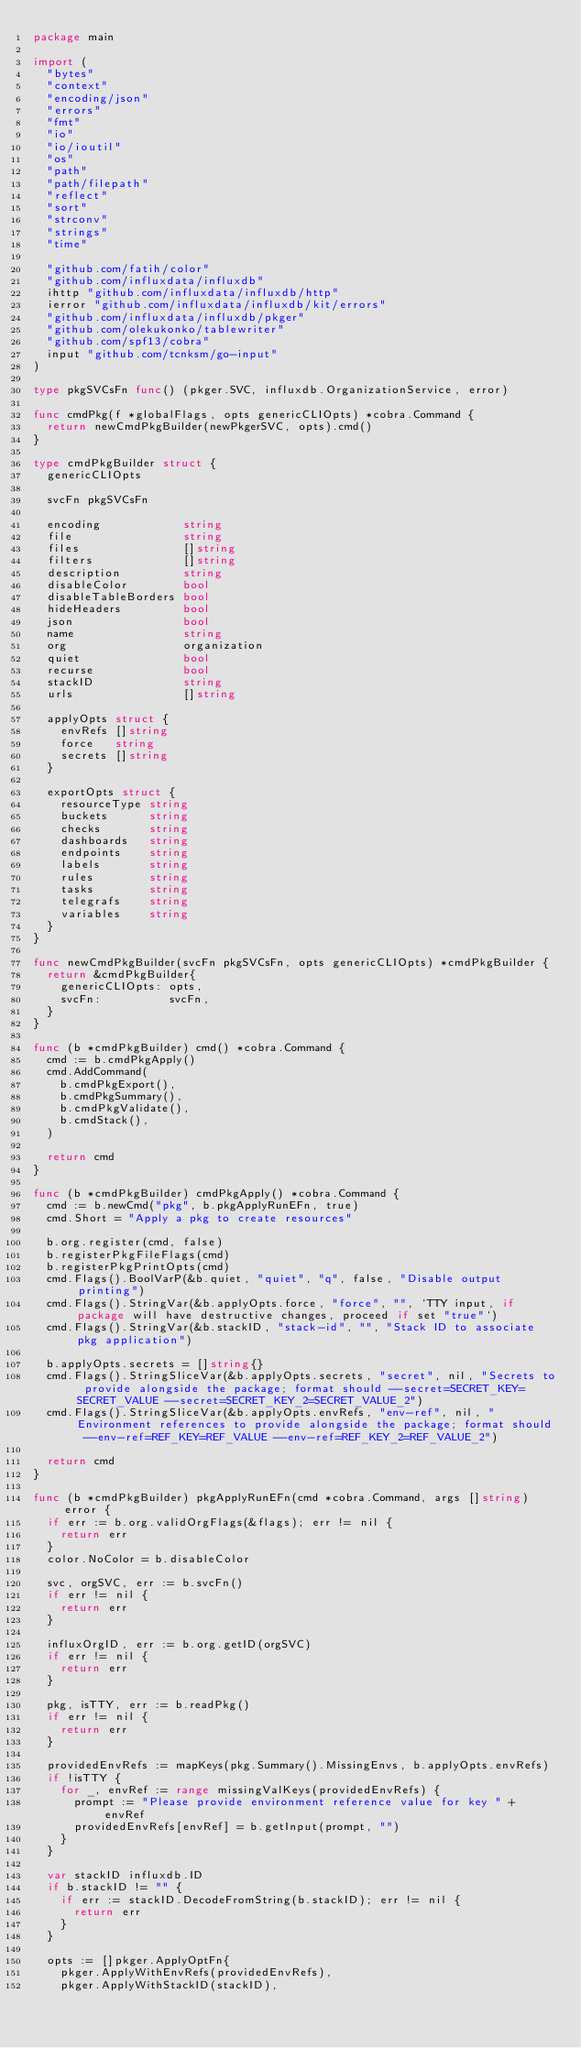Convert code to text. <code><loc_0><loc_0><loc_500><loc_500><_Go_>package main

import (
	"bytes"
	"context"
	"encoding/json"
	"errors"
	"fmt"
	"io"
	"io/ioutil"
	"os"
	"path"
	"path/filepath"
	"reflect"
	"sort"
	"strconv"
	"strings"
	"time"

	"github.com/fatih/color"
	"github.com/influxdata/influxdb"
	ihttp "github.com/influxdata/influxdb/http"
	ierror "github.com/influxdata/influxdb/kit/errors"
	"github.com/influxdata/influxdb/pkger"
	"github.com/olekukonko/tablewriter"
	"github.com/spf13/cobra"
	input "github.com/tcnksm/go-input"
)

type pkgSVCsFn func() (pkger.SVC, influxdb.OrganizationService, error)

func cmdPkg(f *globalFlags, opts genericCLIOpts) *cobra.Command {
	return newCmdPkgBuilder(newPkgerSVC, opts).cmd()
}

type cmdPkgBuilder struct {
	genericCLIOpts

	svcFn pkgSVCsFn

	encoding            string
	file                string
	files               []string
	filters             []string
	description         string
	disableColor        bool
	disableTableBorders bool
	hideHeaders         bool
	json                bool
	name                string
	org                 organization
	quiet               bool
	recurse             bool
	stackID             string
	urls                []string

	applyOpts struct {
		envRefs []string
		force   string
		secrets []string
	}

	exportOpts struct {
		resourceType string
		buckets      string
		checks       string
		dashboards   string
		endpoints    string
		labels       string
		rules        string
		tasks        string
		telegrafs    string
		variables    string
	}
}

func newCmdPkgBuilder(svcFn pkgSVCsFn, opts genericCLIOpts) *cmdPkgBuilder {
	return &cmdPkgBuilder{
		genericCLIOpts: opts,
		svcFn:          svcFn,
	}
}

func (b *cmdPkgBuilder) cmd() *cobra.Command {
	cmd := b.cmdPkgApply()
	cmd.AddCommand(
		b.cmdPkgExport(),
		b.cmdPkgSummary(),
		b.cmdPkgValidate(),
		b.cmdStack(),
	)

	return cmd
}

func (b *cmdPkgBuilder) cmdPkgApply() *cobra.Command {
	cmd := b.newCmd("pkg", b.pkgApplyRunEFn, true)
	cmd.Short = "Apply a pkg to create resources"

	b.org.register(cmd, false)
	b.registerPkgFileFlags(cmd)
	b.registerPkgPrintOpts(cmd)
	cmd.Flags().BoolVarP(&b.quiet, "quiet", "q", false, "Disable output printing")
	cmd.Flags().StringVar(&b.applyOpts.force, "force", "", `TTY input, if package will have destructive changes, proceed if set "true"`)
	cmd.Flags().StringVar(&b.stackID, "stack-id", "", "Stack ID to associate pkg application")

	b.applyOpts.secrets = []string{}
	cmd.Flags().StringSliceVar(&b.applyOpts.secrets, "secret", nil, "Secrets to provide alongside the package; format should --secret=SECRET_KEY=SECRET_VALUE --secret=SECRET_KEY_2=SECRET_VALUE_2")
	cmd.Flags().StringSliceVar(&b.applyOpts.envRefs, "env-ref", nil, "Environment references to provide alongside the package; format should --env-ref=REF_KEY=REF_VALUE --env-ref=REF_KEY_2=REF_VALUE_2")

	return cmd
}

func (b *cmdPkgBuilder) pkgApplyRunEFn(cmd *cobra.Command, args []string) error {
	if err := b.org.validOrgFlags(&flags); err != nil {
		return err
	}
	color.NoColor = b.disableColor

	svc, orgSVC, err := b.svcFn()
	if err != nil {
		return err
	}

	influxOrgID, err := b.org.getID(orgSVC)
	if err != nil {
		return err
	}

	pkg, isTTY, err := b.readPkg()
	if err != nil {
		return err
	}

	providedEnvRefs := mapKeys(pkg.Summary().MissingEnvs, b.applyOpts.envRefs)
	if !isTTY {
		for _, envRef := range missingValKeys(providedEnvRefs) {
			prompt := "Please provide environment reference value for key " + envRef
			providedEnvRefs[envRef] = b.getInput(prompt, "")
		}
	}

	var stackID influxdb.ID
	if b.stackID != "" {
		if err := stackID.DecodeFromString(b.stackID); err != nil {
			return err
		}
	}

	opts := []pkger.ApplyOptFn{
		pkger.ApplyWithEnvRefs(providedEnvRefs),
		pkger.ApplyWithStackID(stackID),</code> 